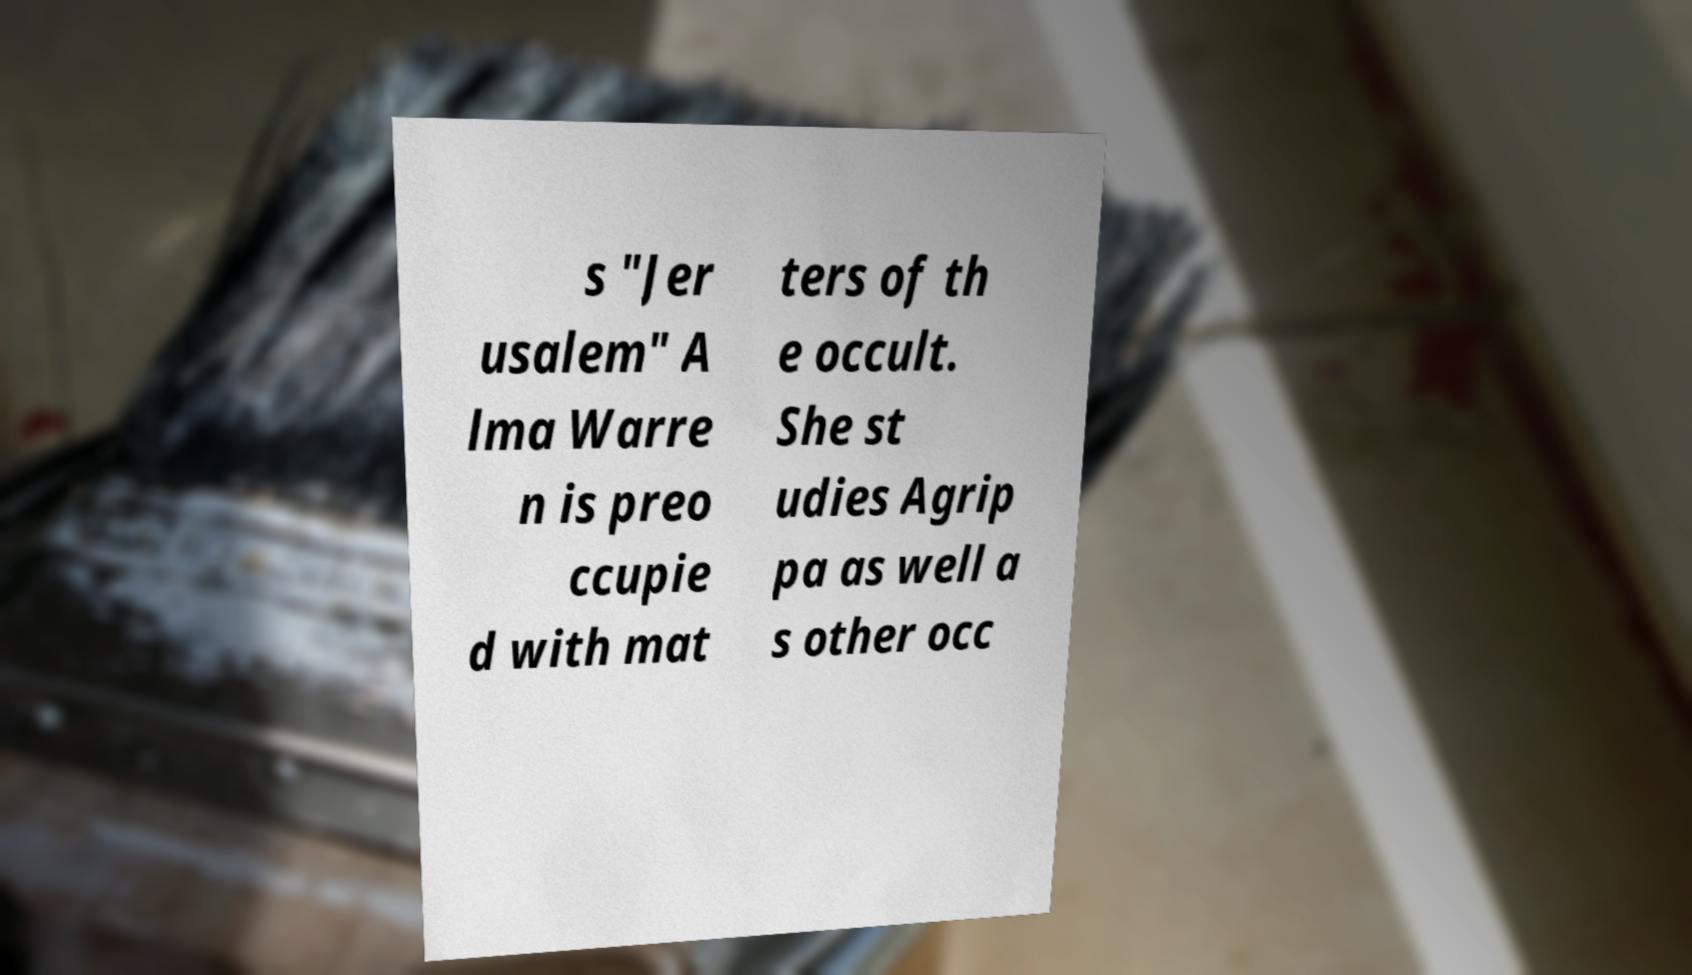Please read and relay the text visible in this image. What does it say? s "Jer usalem" A lma Warre n is preo ccupie d with mat ters of th e occult. She st udies Agrip pa as well a s other occ 